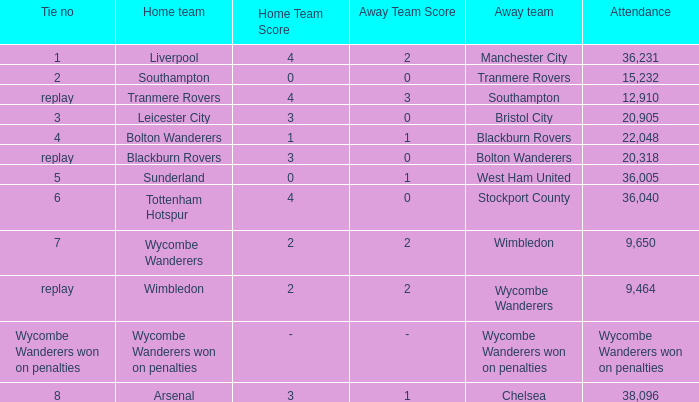What was the attendance for the game where the away team was Stockport County? 36040.0. 